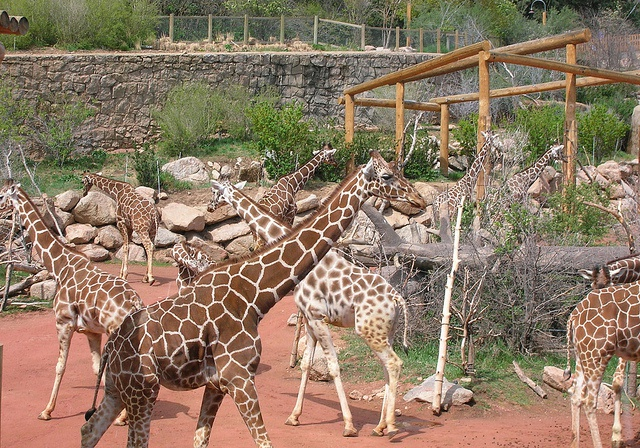Describe the objects in this image and their specific colors. I can see giraffe in olive, brown, maroon, and gray tones, giraffe in olive, lightgray, gray, and tan tones, giraffe in olive, brown, lightgray, and tan tones, giraffe in olive, brown, tan, and lightgray tones, and giraffe in olive, gray, tan, maroon, and brown tones in this image. 